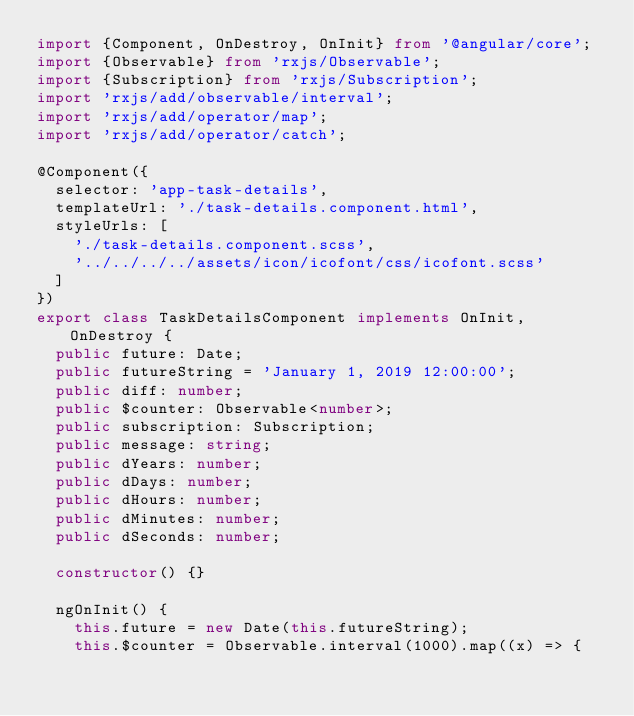<code> <loc_0><loc_0><loc_500><loc_500><_TypeScript_>import {Component, OnDestroy, OnInit} from '@angular/core';
import {Observable} from 'rxjs/Observable';
import {Subscription} from 'rxjs/Subscription';
import 'rxjs/add/observable/interval';
import 'rxjs/add/operator/map';
import 'rxjs/add/operator/catch';

@Component({
  selector: 'app-task-details',
  templateUrl: './task-details.component.html',
  styleUrls: [
    './task-details.component.scss',
    '../../../../assets/icon/icofont/css/icofont.scss'
  ]
})
export class TaskDetailsComponent implements OnInit, OnDestroy {
  public future: Date;
  public futureString = 'January 1, 2019 12:00:00';
  public diff: number;
  public $counter: Observable<number>;
  public subscription: Subscription;
  public message: string;
  public dYears: number;
  public dDays: number;
  public dHours: number;
  public dMinutes: number;
  public dSeconds: number;

  constructor() {}

  ngOnInit() {
    this.future = new Date(this.futureString);
    this.$counter = Observable.interval(1000).map((x) => {</code> 